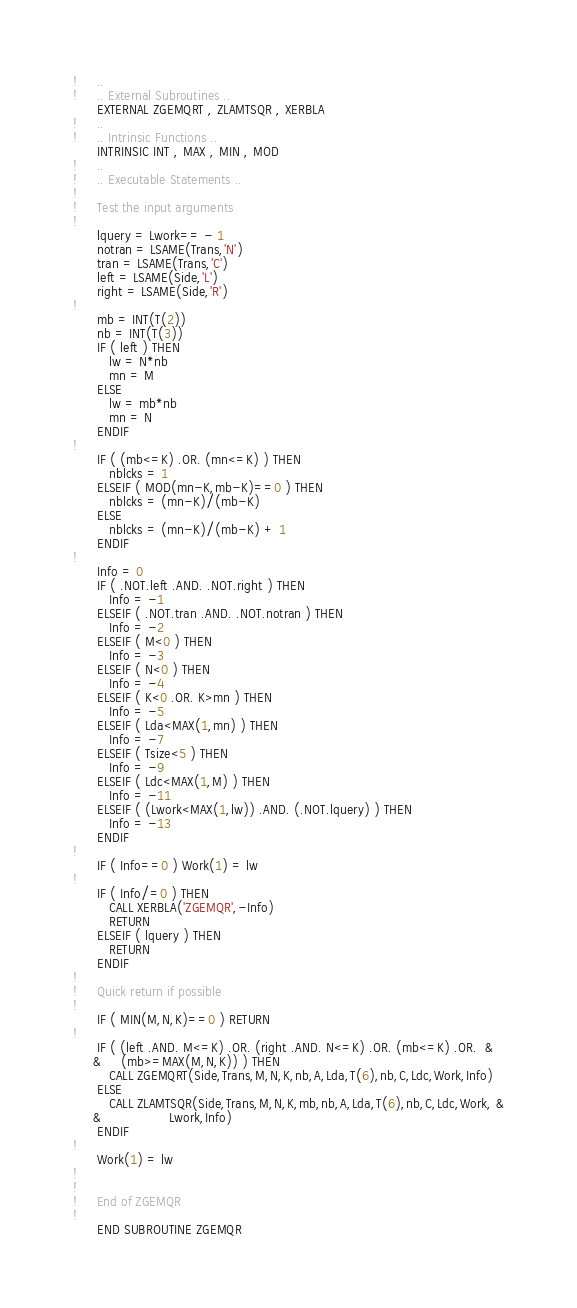<code> <loc_0><loc_0><loc_500><loc_500><_FORTRAN_>!     ..
!     .. External Subroutines ..
      EXTERNAL ZGEMQRT , ZLAMTSQR , XERBLA
!     ..
!     .. Intrinsic Functions ..
      INTRINSIC INT , MAX , MIN , MOD
!     ..
!     .. Executable Statements ..
!
!     Test the input arguments
!
      lquery = Lwork== - 1
      notran = LSAME(Trans,'N')
      tran = LSAME(Trans,'C')
      left = LSAME(Side,'L')
      right = LSAME(Side,'R')
!
      mb = INT(T(2))
      nb = INT(T(3))
      IF ( left ) THEN
         lw = N*nb
         mn = M
      ELSE
         lw = mb*nb
         mn = N
      ENDIF
!
      IF ( (mb<=K) .OR. (mn<=K) ) THEN
         nblcks = 1
      ELSEIF ( MOD(mn-K,mb-K)==0 ) THEN
         nblcks = (mn-K)/(mb-K)
      ELSE
         nblcks = (mn-K)/(mb-K) + 1
      ENDIF
!
      Info = 0
      IF ( .NOT.left .AND. .NOT.right ) THEN
         Info = -1
      ELSEIF ( .NOT.tran .AND. .NOT.notran ) THEN
         Info = -2
      ELSEIF ( M<0 ) THEN
         Info = -3
      ELSEIF ( N<0 ) THEN
         Info = -4
      ELSEIF ( K<0 .OR. K>mn ) THEN
         Info = -5
      ELSEIF ( Lda<MAX(1,mn) ) THEN
         Info = -7
      ELSEIF ( Tsize<5 ) THEN
         Info = -9
      ELSEIF ( Ldc<MAX(1,M) ) THEN
         Info = -11
      ELSEIF ( (Lwork<MAX(1,lw)) .AND. (.NOT.lquery) ) THEN
         Info = -13
      ENDIF
!
      IF ( Info==0 ) Work(1) = lw
!
      IF ( Info/=0 ) THEN
         CALL XERBLA('ZGEMQR',-Info)
         RETURN
      ELSEIF ( lquery ) THEN
         RETURN
      ENDIF
!
!     Quick return if possible
!
      IF ( MIN(M,N,K)==0 ) RETURN
!
      IF ( (left .AND. M<=K) .OR. (right .AND. N<=K) .OR. (mb<=K) .OR.  &
     &     (mb>=MAX(M,N,K)) ) THEN
         CALL ZGEMQRT(Side,Trans,M,N,K,nb,A,Lda,T(6),nb,C,Ldc,Work,Info)
      ELSE
         CALL ZLAMTSQR(Side,Trans,M,N,K,mb,nb,A,Lda,T(6),nb,C,Ldc,Work, &
     &                 Lwork,Info)
      ENDIF
!
      Work(1) = lw
!
!
!     End of ZGEMQR
!
      END SUBROUTINE ZGEMQR
</code> 